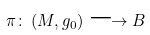<formula> <loc_0><loc_0><loc_500><loc_500>\pi \colon \left ( M , g _ { 0 } \right ) \longrightarrow B</formula> 